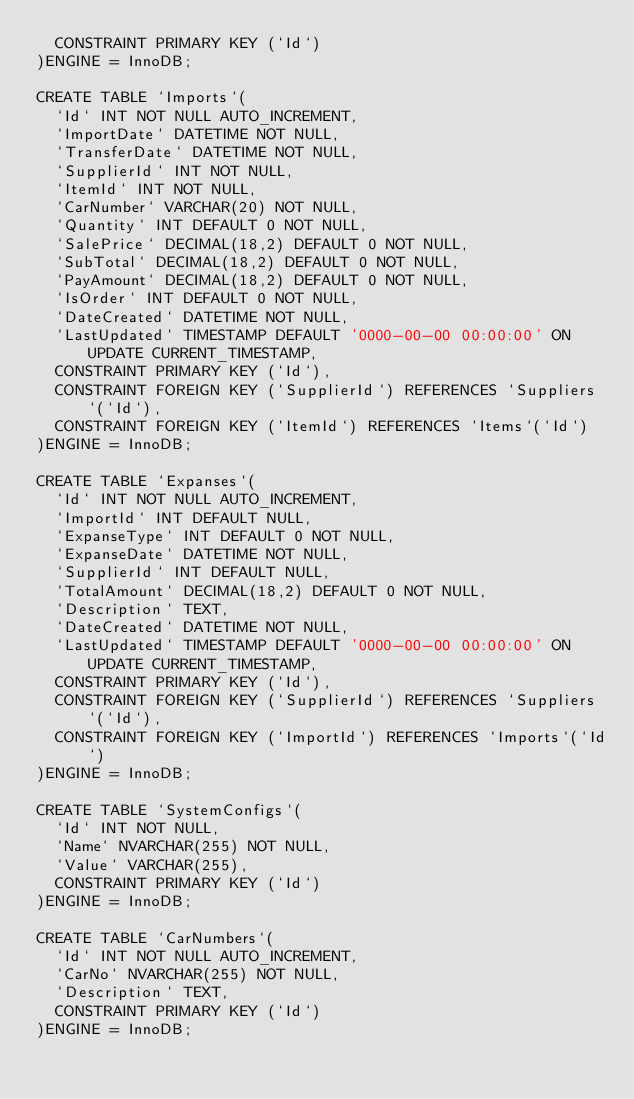<code> <loc_0><loc_0><loc_500><loc_500><_SQL_>	CONSTRAINT PRIMARY KEY (`Id`)
)ENGINE = InnoDB;

CREATE TABLE `Imports`(
	`Id` INT NOT NULL AUTO_INCREMENT,
	`ImportDate` DATETIME NOT NULL,
	`TransferDate` DATETIME NOT NULL,
	`SupplierId` INT NOT NULL,
	`ItemId` INT NOT NULL,
	`CarNumber` VARCHAR(20) NOT NULL,
	`Quantity` INT DEFAULT 0 NOT NULL,
	`SalePrice` DECIMAL(18,2) DEFAULT 0 NOT NULL,
	`SubTotal` DECIMAL(18,2) DEFAULT 0 NOT NULL,
	`PayAmount` DECIMAL(18,2) DEFAULT 0 NOT NULL,
	`IsOrder` INT DEFAULT 0 NOT NULL,
	`DateCreated` DATETIME NOT NULL,
	`LastUpdated` TIMESTAMP DEFAULT '0000-00-00 00:00:00' ON UPDATE CURRENT_TIMESTAMP,
	CONSTRAINT PRIMARY KEY (`Id`),
	CONSTRAINT FOREIGN KEY (`SupplierId`) REFERENCES `Suppliers`(`Id`),
	CONSTRAINT FOREIGN KEY (`ItemId`) REFERENCES `Items`(`Id`)
)ENGINE = InnoDB;

CREATE TABLE `Expanses`(
	`Id` INT NOT NULL AUTO_INCREMENT,
	`ImportId` INT DEFAULT NULL,
	`ExpanseType` INT DEFAULT 0 NOT NULL,
	`ExpanseDate` DATETIME NOT NULL,
	`SupplierId` INT DEFAULT NULL,
	`TotalAmount` DECIMAL(18,2) DEFAULT 0 NOT NULL,
	`Description` TEXT,
	`DateCreated` DATETIME NOT NULL,
	`LastUpdated` TIMESTAMP DEFAULT '0000-00-00 00:00:00' ON UPDATE CURRENT_TIMESTAMP,
	CONSTRAINT PRIMARY KEY (`Id`),
	CONSTRAINT FOREIGN KEY (`SupplierId`) REFERENCES `Suppliers`(`Id`),
	CONSTRAINT FOREIGN KEY (`ImportId`) REFERENCES `Imports`(`Id`)
)ENGINE = InnoDB;

CREATE TABLE `SystemConfigs`(
	`Id` INT NOT NULL,
	`Name` NVARCHAR(255) NOT NULL,
	`Value` VARCHAR(255),
	CONSTRAINT PRIMARY KEY (`Id`)
)ENGINE = InnoDB;

CREATE TABLE `CarNumbers`(
	`Id` INT NOT NULL AUTO_INCREMENT,
	`CarNo` NVARCHAR(255) NOT NULL,
	`Description` TEXT,
	CONSTRAINT PRIMARY KEY (`Id`)
)ENGINE = InnoDB;
</code> 